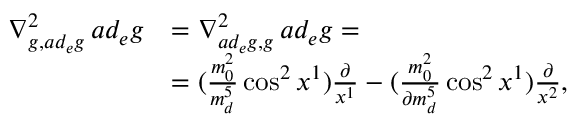<formula> <loc_0><loc_0><loc_500><loc_500>\begin{array} { r l } { \nabla _ { g , a d _ { e } g } ^ { 2 } \, a d _ { e } g } & { = \nabla _ { a d _ { e } g , g } ^ { 2 } \, a d _ { e } g = } \\ & { = ( \frac { m _ { 0 } ^ { 2 } } { m _ { d } ^ { 5 } } \cos ^ { 2 } x ^ { 1 } ) \frac { \partial } { x ^ { 1 } } - ( \frac { m _ { 0 } ^ { 2 } } { \partial m _ { d } ^ { 5 } } \cos ^ { 2 } x ^ { 1 } ) \frac { \partial } { x ^ { 2 } } , } \end{array}</formula> 